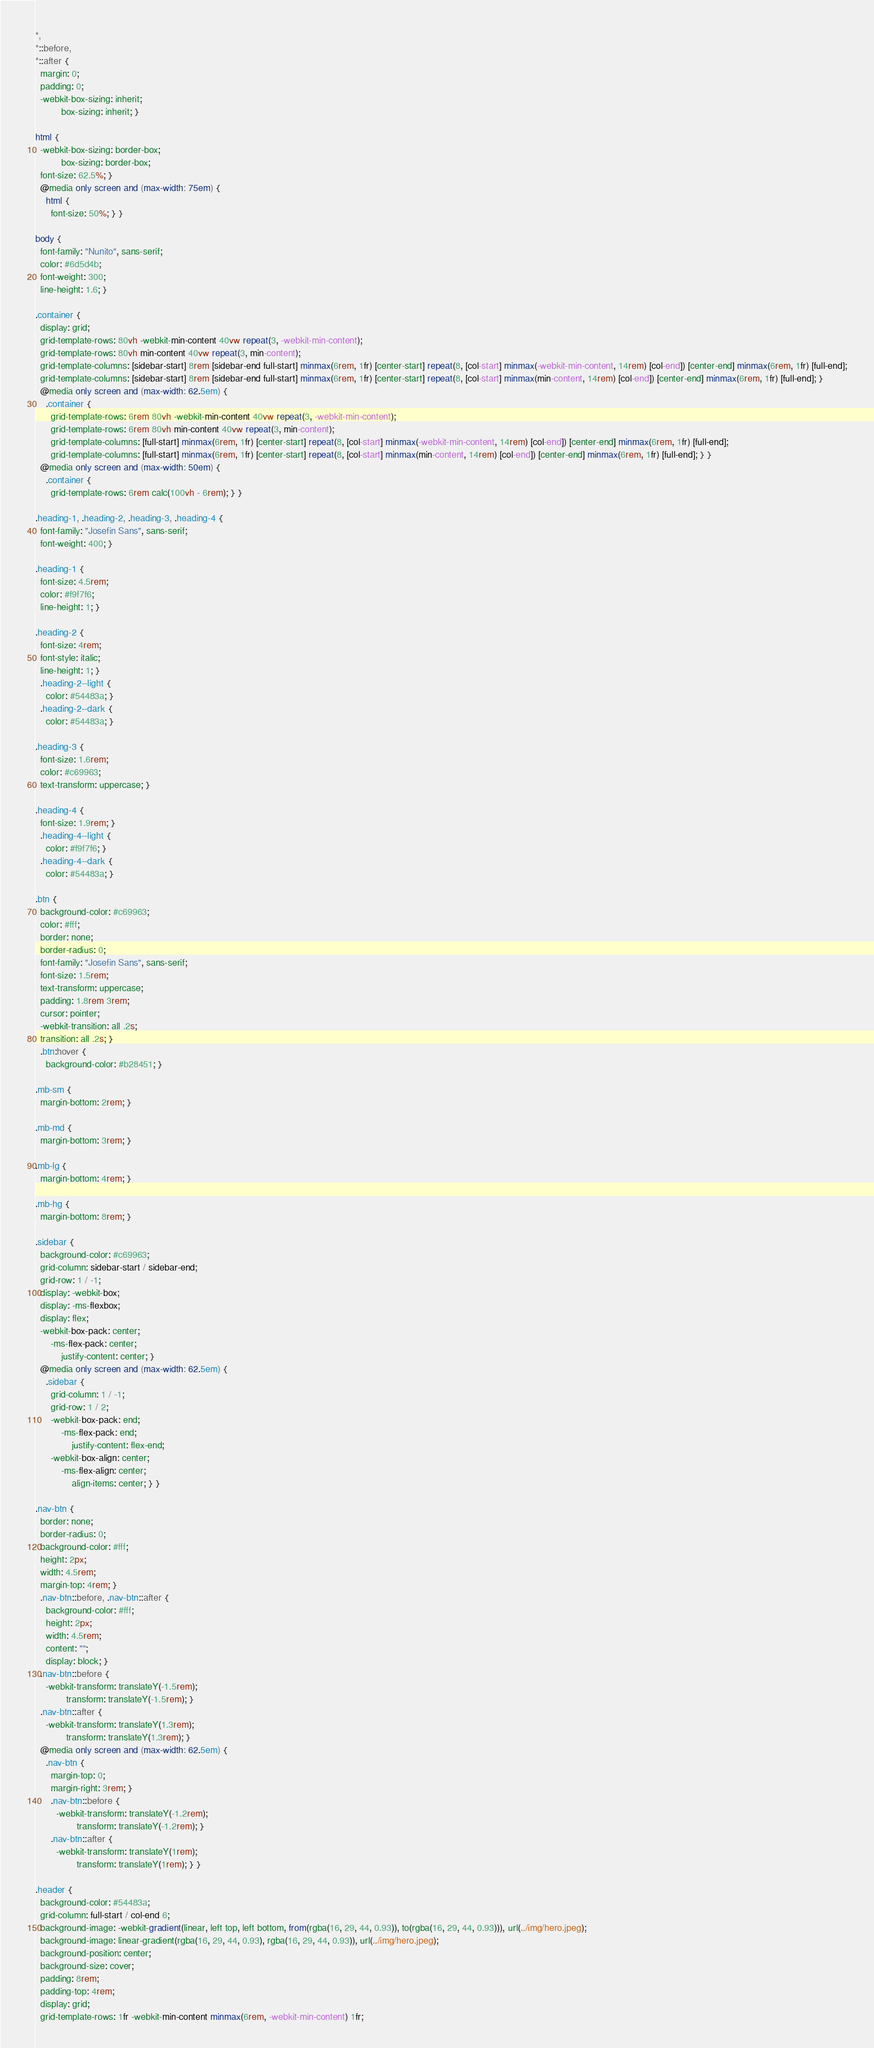Convert code to text. <code><loc_0><loc_0><loc_500><loc_500><_CSS_>*,
*::before,
*::after {
  margin: 0;
  padding: 0;
  -webkit-box-sizing: inherit;
          box-sizing: inherit; }

html {
  -webkit-box-sizing: border-box;
          box-sizing: border-box;
  font-size: 62.5%; }
  @media only screen and (max-width: 75em) {
    html {
      font-size: 50%; } }

body {
  font-family: "Nunito", sans-serif;
  color: #6d5d4b;
  font-weight: 300;
  line-height: 1.6; }

.container {
  display: grid;
  grid-template-rows: 80vh -webkit-min-content 40vw repeat(3, -webkit-min-content);
  grid-template-rows: 80vh min-content 40vw repeat(3, min-content);
  grid-template-columns: [sidebar-start] 8rem [sidebar-end full-start] minmax(6rem, 1fr) [center-start] repeat(8, [col-start] minmax(-webkit-min-content, 14rem) [col-end]) [center-end] minmax(6rem, 1fr) [full-end];
  grid-template-columns: [sidebar-start] 8rem [sidebar-end full-start] minmax(6rem, 1fr) [center-start] repeat(8, [col-start] minmax(min-content, 14rem) [col-end]) [center-end] minmax(6rem, 1fr) [full-end]; }
  @media only screen and (max-width: 62.5em) {
    .container {
      grid-template-rows: 6rem 80vh -webkit-min-content 40vw repeat(3, -webkit-min-content);
      grid-template-rows: 6rem 80vh min-content 40vw repeat(3, min-content);
      grid-template-columns: [full-start] minmax(6rem, 1fr) [center-start] repeat(8, [col-start] minmax(-webkit-min-content, 14rem) [col-end]) [center-end] minmax(6rem, 1fr) [full-end];
      grid-template-columns: [full-start] minmax(6rem, 1fr) [center-start] repeat(8, [col-start] minmax(min-content, 14rem) [col-end]) [center-end] minmax(6rem, 1fr) [full-end]; } }
  @media only screen and (max-width: 50em) {
    .container {
      grid-template-rows: 6rem calc(100vh - 6rem); } }

.heading-1, .heading-2, .heading-3, .heading-4 {
  font-family: "Josefin Sans", sans-serif;
  font-weight: 400; }

.heading-1 {
  font-size: 4.5rem;
  color: #f9f7f6;
  line-height: 1; }

.heading-2 {
  font-size: 4rem;
  font-style: italic;
  line-height: 1; }
  .heading-2--light {
    color: #54483a; }
  .heading-2--dark {
    color: #54483a; }

.heading-3 {
  font-size: 1.6rem;
  color: #c69963;
  text-transform: uppercase; }

.heading-4 {
  font-size: 1.9rem; }
  .heading-4--light {
    color: #f9f7f6; }
  .heading-4--dark {
    color: #54483a; }

.btn {
  background-color: #c69963;
  color: #fff;
  border: none;
  border-radius: 0;
  font-family: "Josefin Sans", sans-serif;
  font-size: 1.5rem;
  text-transform: uppercase;
  padding: 1.8rem 3rem;
  cursor: pointer;
  -webkit-transition: all .2s;
  transition: all .2s; }
  .btn:hover {
    background-color: #b28451; }

.mb-sm {
  margin-bottom: 2rem; }

.mb-md {
  margin-bottom: 3rem; }

.mb-lg {
  margin-bottom: 4rem; }

.mb-hg {
  margin-bottom: 8rem; }

.sidebar {
  background-color: #c69963;
  grid-column: sidebar-start / sidebar-end;
  grid-row: 1 / -1;
  display: -webkit-box;
  display: -ms-flexbox;
  display: flex;
  -webkit-box-pack: center;
      -ms-flex-pack: center;
          justify-content: center; }
  @media only screen and (max-width: 62.5em) {
    .sidebar {
      grid-column: 1 / -1;
      grid-row: 1 / 2;
      -webkit-box-pack: end;
          -ms-flex-pack: end;
              justify-content: flex-end;
      -webkit-box-align: center;
          -ms-flex-align: center;
              align-items: center; } }

.nav-btn {
  border: none;
  border-radius: 0;
  background-color: #fff;
  height: 2px;
  width: 4.5rem;
  margin-top: 4rem; }
  .nav-btn::before, .nav-btn::after {
    background-color: #fff;
    height: 2px;
    width: 4.5rem;
    content: "";
    display: block; }
  .nav-btn::before {
    -webkit-transform: translateY(-1.5rem);
            transform: translateY(-1.5rem); }
  .nav-btn::after {
    -webkit-transform: translateY(1.3rem);
            transform: translateY(1.3rem); }
  @media only screen and (max-width: 62.5em) {
    .nav-btn {
      margin-top: 0;
      margin-right: 3rem; }
      .nav-btn::before {
        -webkit-transform: translateY(-1.2rem);
                transform: translateY(-1.2rem); }
      .nav-btn::after {
        -webkit-transform: translateY(1rem);
                transform: translateY(1rem); } }

.header {
  background-color: #54483a;
  grid-column: full-start / col-end 6;
  background-image: -webkit-gradient(linear, left top, left bottom, from(rgba(16, 29, 44, 0.93)), to(rgba(16, 29, 44, 0.93))), url(../img/hero.jpeg);
  background-image: linear-gradient(rgba(16, 29, 44, 0.93), rgba(16, 29, 44, 0.93)), url(../img/hero.jpeg);
  background-position: center;
  background-size: cover;
  padding: 8rem;
  padding-top: 4rem;
  display: grid;
  grid-template-rows: 1fr -webkit-min-content minmax(6rem, -webkit-min-content) 1fr;</code> 